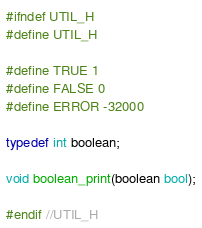Convert code to text. <code><loc_0><loc_0><loc_500><loc_500><_C_>#ifndef UTIL_H
#define UTIL_H

#define TRUE 1
#define FALSE 0
#define ERROR -32000

typedef int boolean;

void boolean_print(boolean bool);

#endif //UTIL_H
</code> 